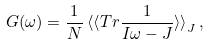Convert formula to latex. <formula><loc_0><loc_0><loc_500><loc_500>G ( \omega ) = \frac { 1 } { N } \, { \langle \langle } T r \frac { 1 } { I \omega - J } { \rangle \rangle } _ { J } \, ,</formula> 